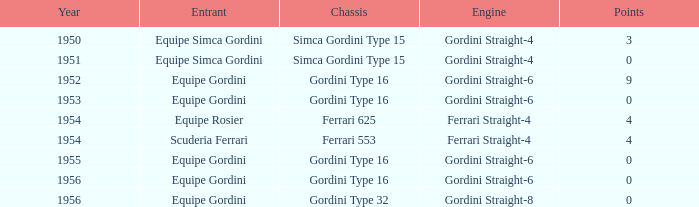What power source was applied by equipe simca gordini preceding 1956 with less than 4 points? Gordini Straight-4, Gordini Straight-4. 